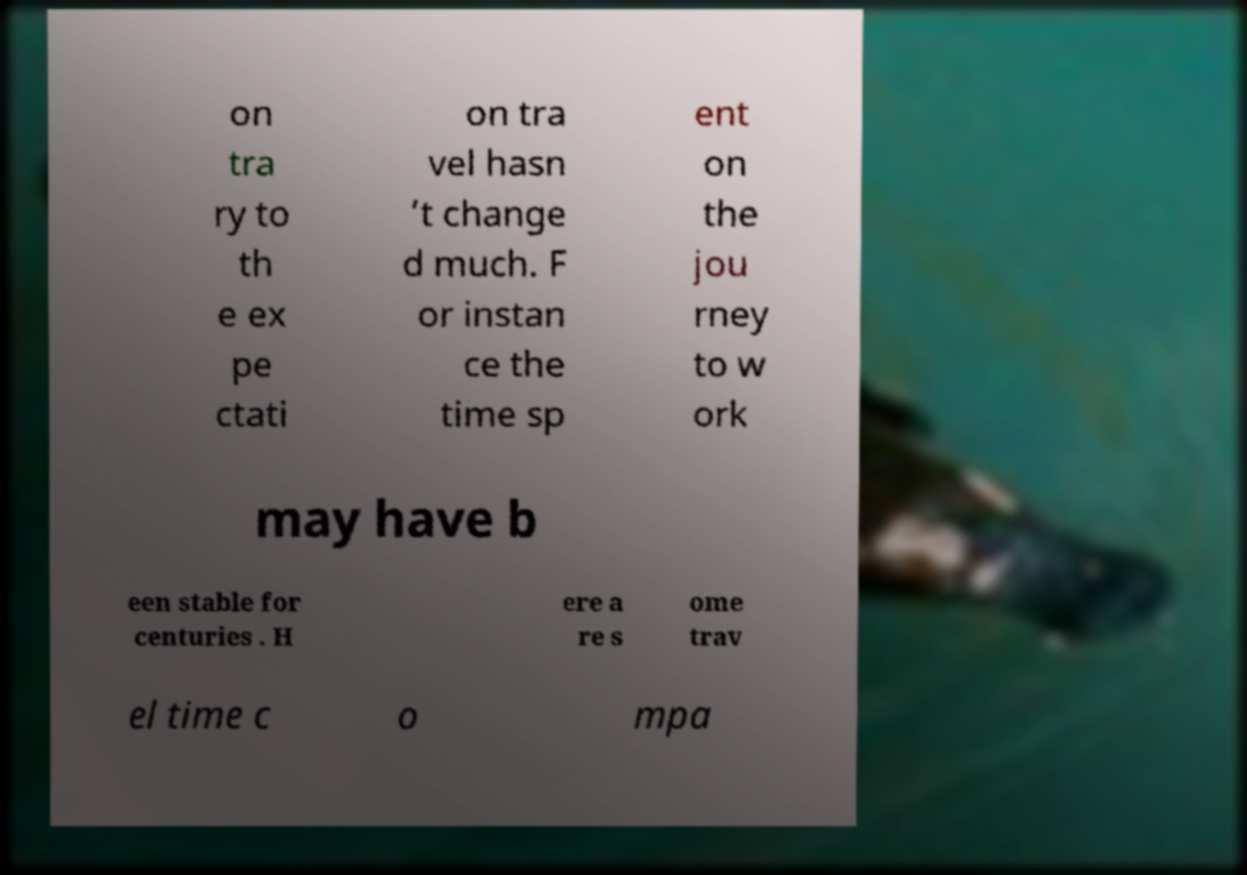Could you extract and type out the text from this image? on tra ry to th e ex pe ctati on tra vel hasn ’t change d much. F or instan ce the time sp ent on the jou rney to w ork may have b een stable for centuries . H ere a re s ome trav el time c o mpa 